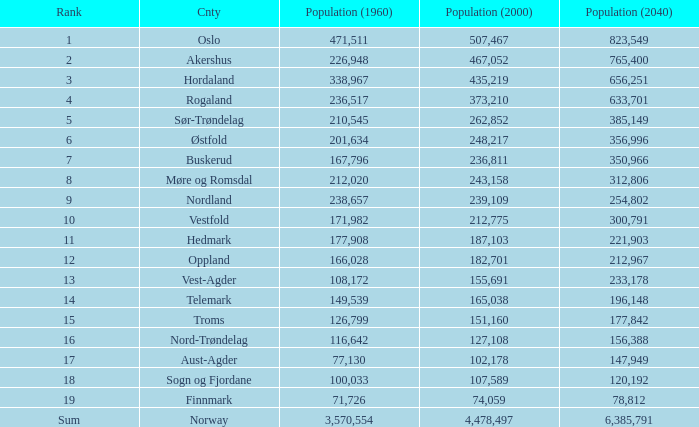What was the population of a county in 1960 that had a population of 467,052 in 2000 and 78,812 in 2040? None. 